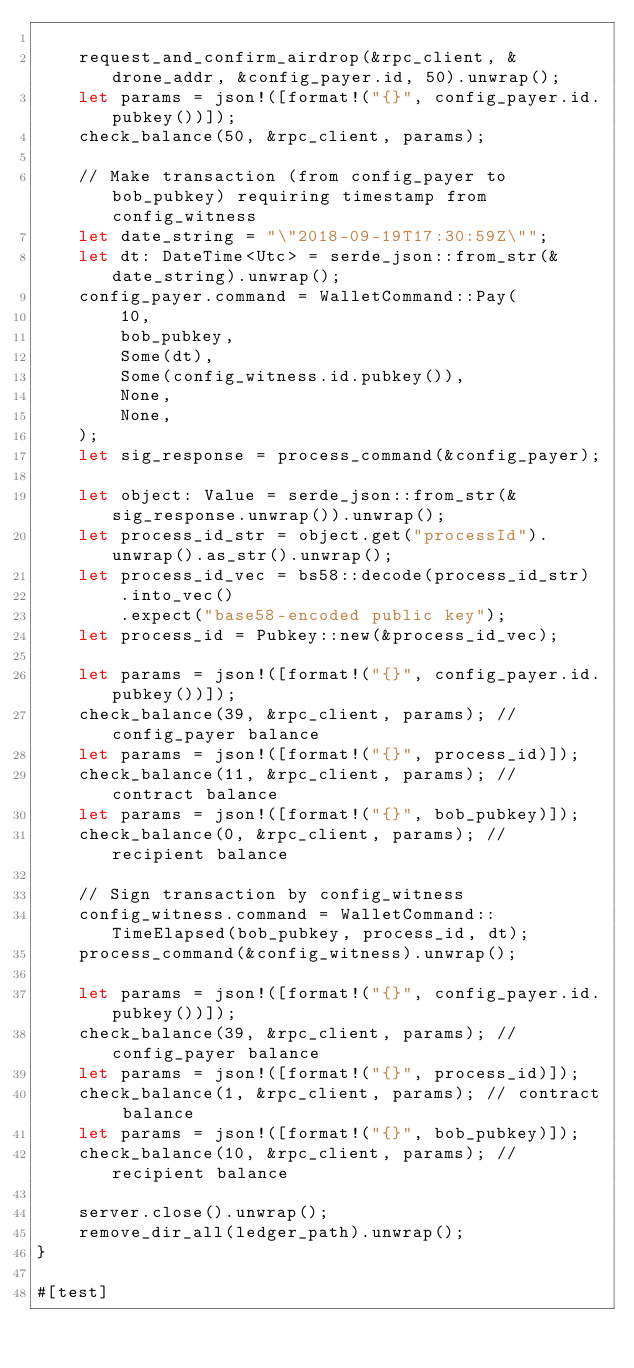Convert code to text. <code><loc_0><loc_0><loc_500><loc_500><_Rust_>
    request_and_confirm_airdrop(&rpc_client, &drone_addr, &config_payer.id, 50).unwrap();
    let params = json!([format!("{}", config_payer.id.pubkey())]);
    check_balance(50, &rpc_client, params);

    // Make transaction (from config_payer to bob_pubkey) requiring timestamp from config_witness
    let date_string = "\"2018-09-19T17:30:59Z\"";
    let dt: DateTime<Utc> = serde_json::from_str(&date_string).unwrap();
    config_payer.command = WalletCommand::Pay(
        10,
        bob_pubkey,
        Some(dt),
        Some(config_witness.id.pubkey()),
        None,
        None,
    );
    let sig_response = process_command(&config_payer);

    let object: Value = serde_json::from_str(&sig_response.unwrap()).unwrap();
    let process_id_str = object.get("processId").unwrap().as_str().unwrap();
    let process_id_vec = bs58::decode(process_id_str)
        .into_vec()
        .expect("base58-encoded public key");
    let process_id = Pubkey::new(&process_id_vec);

    let params = json!([format!("{}", config_payer.id.pubkey())]);
    check_balance(39, &rpc_client, params); // config_payer balance
    let params = json!([format!("{}", process_id)]);
    check_balance(11, &rpc_client, params); // contract balance
    let params = json!([format!("{}", bob_pubkey)]);
    check_balance(0, &rpc_client, params); // recipient balance

    // Sign transaction by config_witness
    config_witness.command = WalletCommand::TimeElapsed(bob_pubkey, process_id, dt);
    process_command(&config_witness).unwrap();

    let params = json!([format!("{}", config_payer.id.pubkey())]);
    check_balance(39, &rpc_client, params); // config_payer balance
    let params = json!([format!("{}", process_id)]);
    check_balance(1, &rpc_client, params); // contract balance
    let params = json!([format!("{}", bob_pubkey)]);
    check_balance(10, &rpc_client, params); // recipient balance

    server.close().unwrap();
    remove_dir_all(ledger_path).unwrap();
}

#[test]</code> 